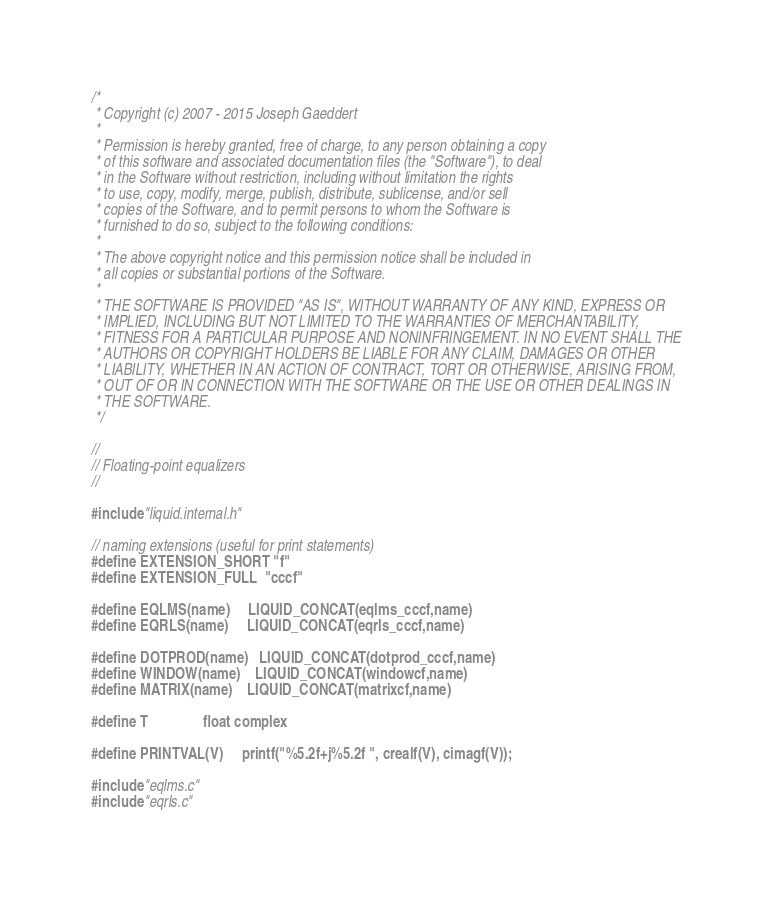Convert code to text. <code><loc_0><loc_0><loc_500><loc_500><_C_>/*
 * Copyright (c) 2007 - 2015 Joseph Gaeddert
 *
 * Permission is hereby granted, free of charge, to any person obtaining a copy
 * of this software and associated documentation files (the "Software"), to deal
 * in the Software without restriction, including without limitation the rights
 * to use, copy, modify, merge, publish, distribute, sublicense, and/or sell
 * copies of the Software, and to permit persons to whom the Software is
 * furnished to do so, subject to the following conditions:
 *
 * The above copyright notice and this permission notice shall be included in
 * all copies or substantial portions of the Software.
 *
 * THE SOFTWARE IS PROVIDED "AS IS", WITHOUT WARRANTY OF ANY KIND, EXPRESS OR
 * IMPLIED, INCLUDING BUT NOT LIMITED TO THE WARRANTIES OF MERCHANTABILITY,
 * FITNESS FOR A PARTICULAR PURPOSE AND NONINFRINGEMENT. IN NO EVENT SHALL THE
 * AUTHORS OR COPYRIGHT HOLDERS BE LIABLE FOR ANY CLAIM, DAMAGES OR OTHER
 * LIABILITY, WHETHER IN AN ACTION OF CONTRACT, TORT OR OTHERWISE, ARISING FROM,
 * OUT OF OR IN CONNECTION WITH THE SOFTWARE OR THE USE OR OTHER DEALINGS IN
 * THE SOFTWARE.
 */

// 
// Floating-point equalizers
//

#include "liquid.internal.h"

// naming extensions (useful for print statements)
#define EXTENSION_SHORT "f"
#define EXTENSION_FULL  "cccf"

#define EQLMS(name)     LIQUID_CONCAT(eqlms_cccf,name)
#define EQRLS(name)     LIQUID_CONCAT(eqrls_cccf,name)

#define DOTPROD(name)   LIQUID_CONCAT(dotprod_cccf,name)
#define WINDOW(name)    LIQUID_CONCAT(windowcf,name)
#define MATRIX(name)    LIQUID_CONCAT(matrixcf,name)

#define T               float complex

#define PRINTVAL(V)     printf("%5.2f+j%5.2f ", crealf(V), cimagf(V));

#include "eqlms.c"
#include "eqrls.c"
</code> 